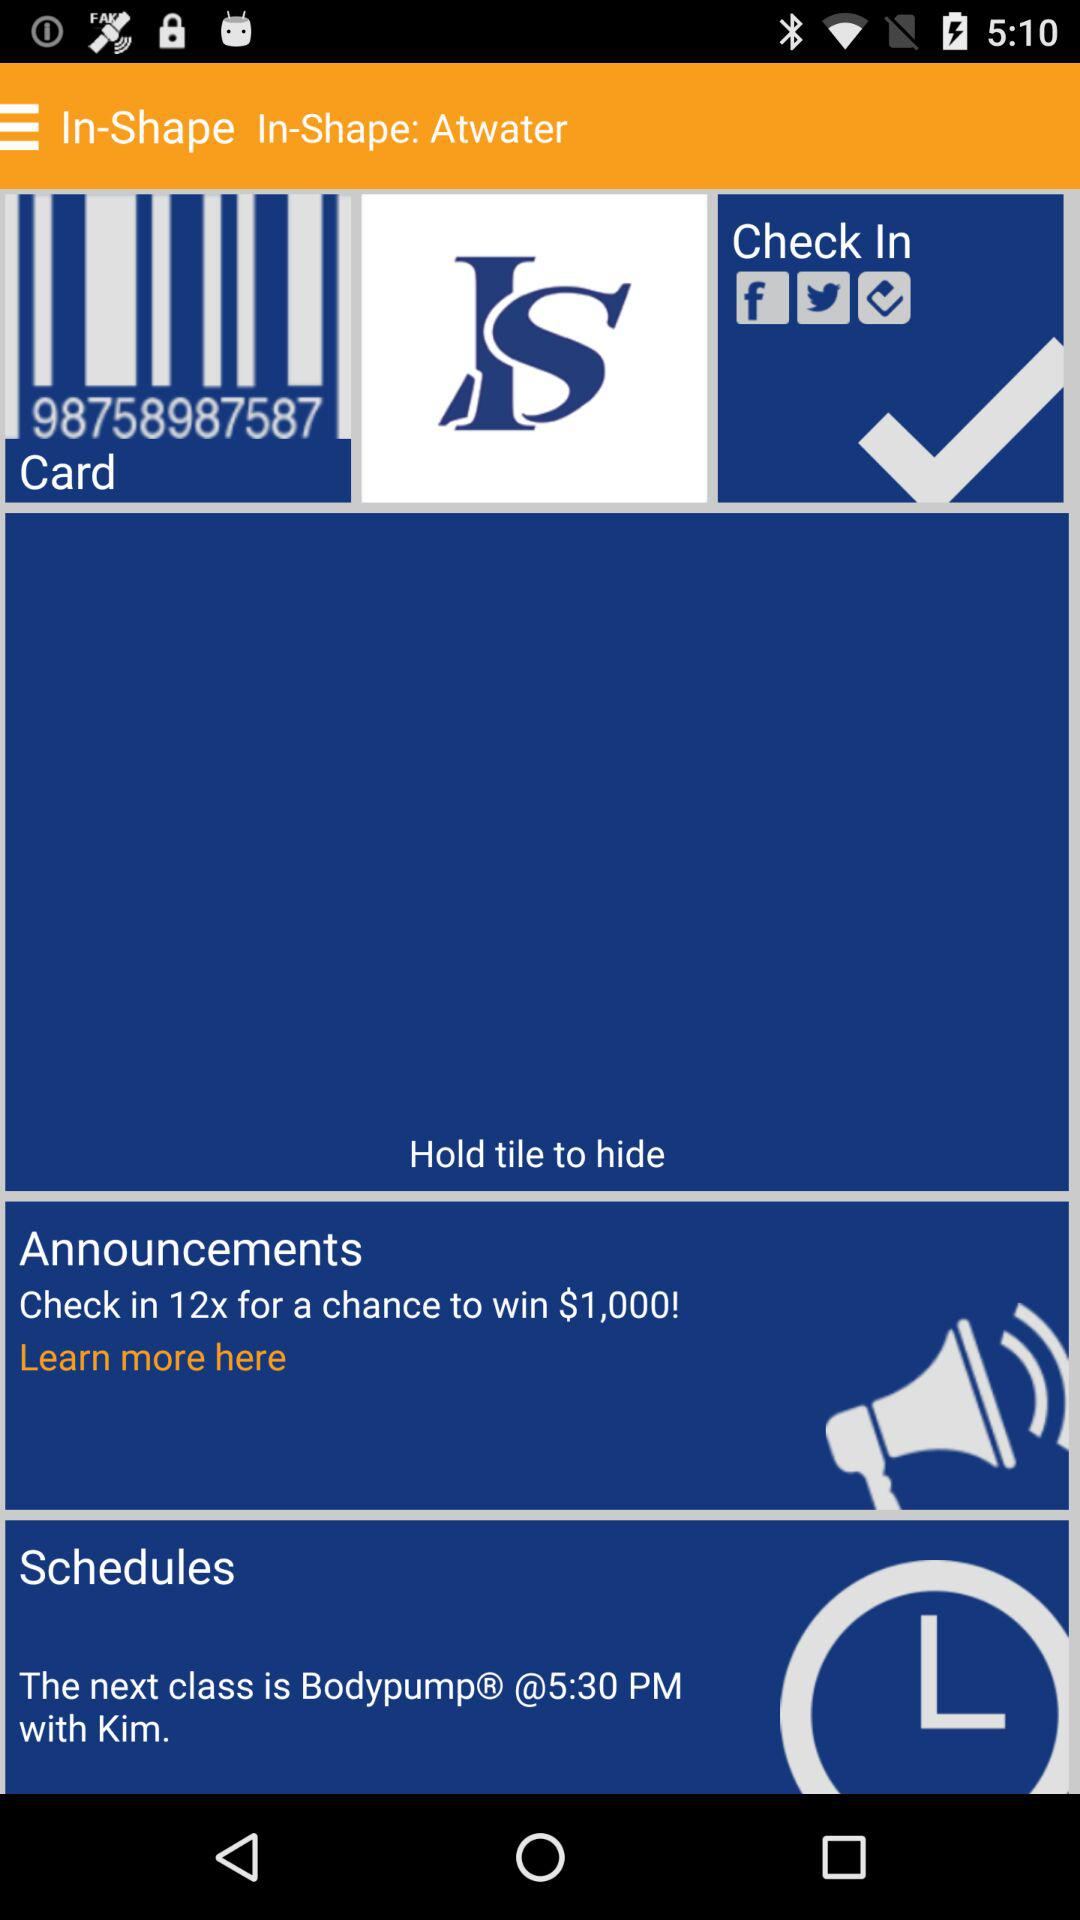What is the announcement? The announcement is "Check in 12x for a chance to win $1,000!". 